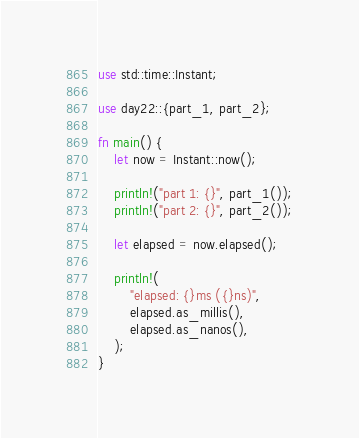<code> <loc_0><loc_0><loc_500><loc_500><_Rust_>use std::time::Instant;

use day22::{part_1, part_2};

fn main() {
    let now = Instant::now();

    println!("part 1: {}", part_1());
    println!("part 2: {}", part_2());

    let elapsed = now.elapsed();

    println!(
        "elapsed: {}ms ({}ns)",
        elapsed.as_millis(),
        elapsed.as_nanos(),
    );
}
</code> 